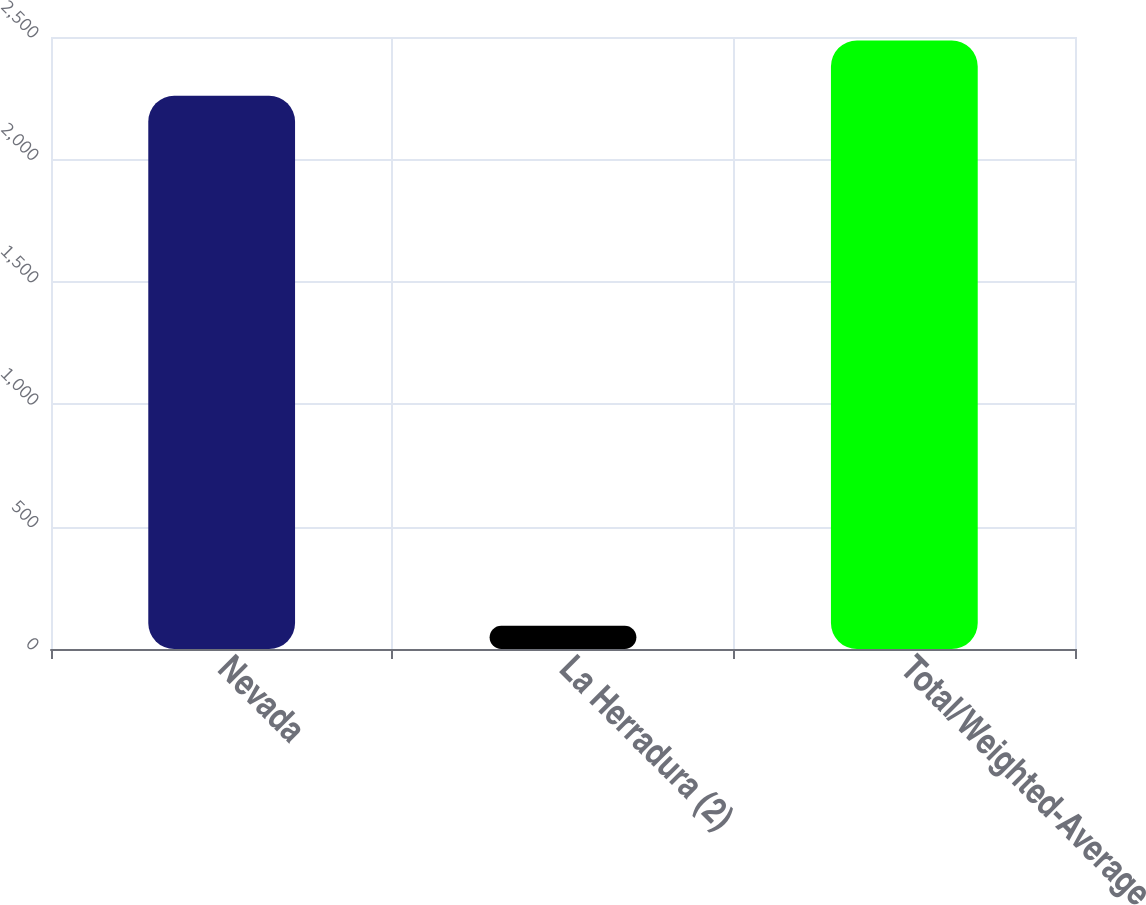Convert chart. <chart><loc_0><loc_0><loc_500><loc_500><bar_chart><fcel>Nevada<fcel>La Herradura (2)<fcel>Total/Weighted-Average<nl><fcel>2260<fcel>95<fcel>2486<nl></chart> 